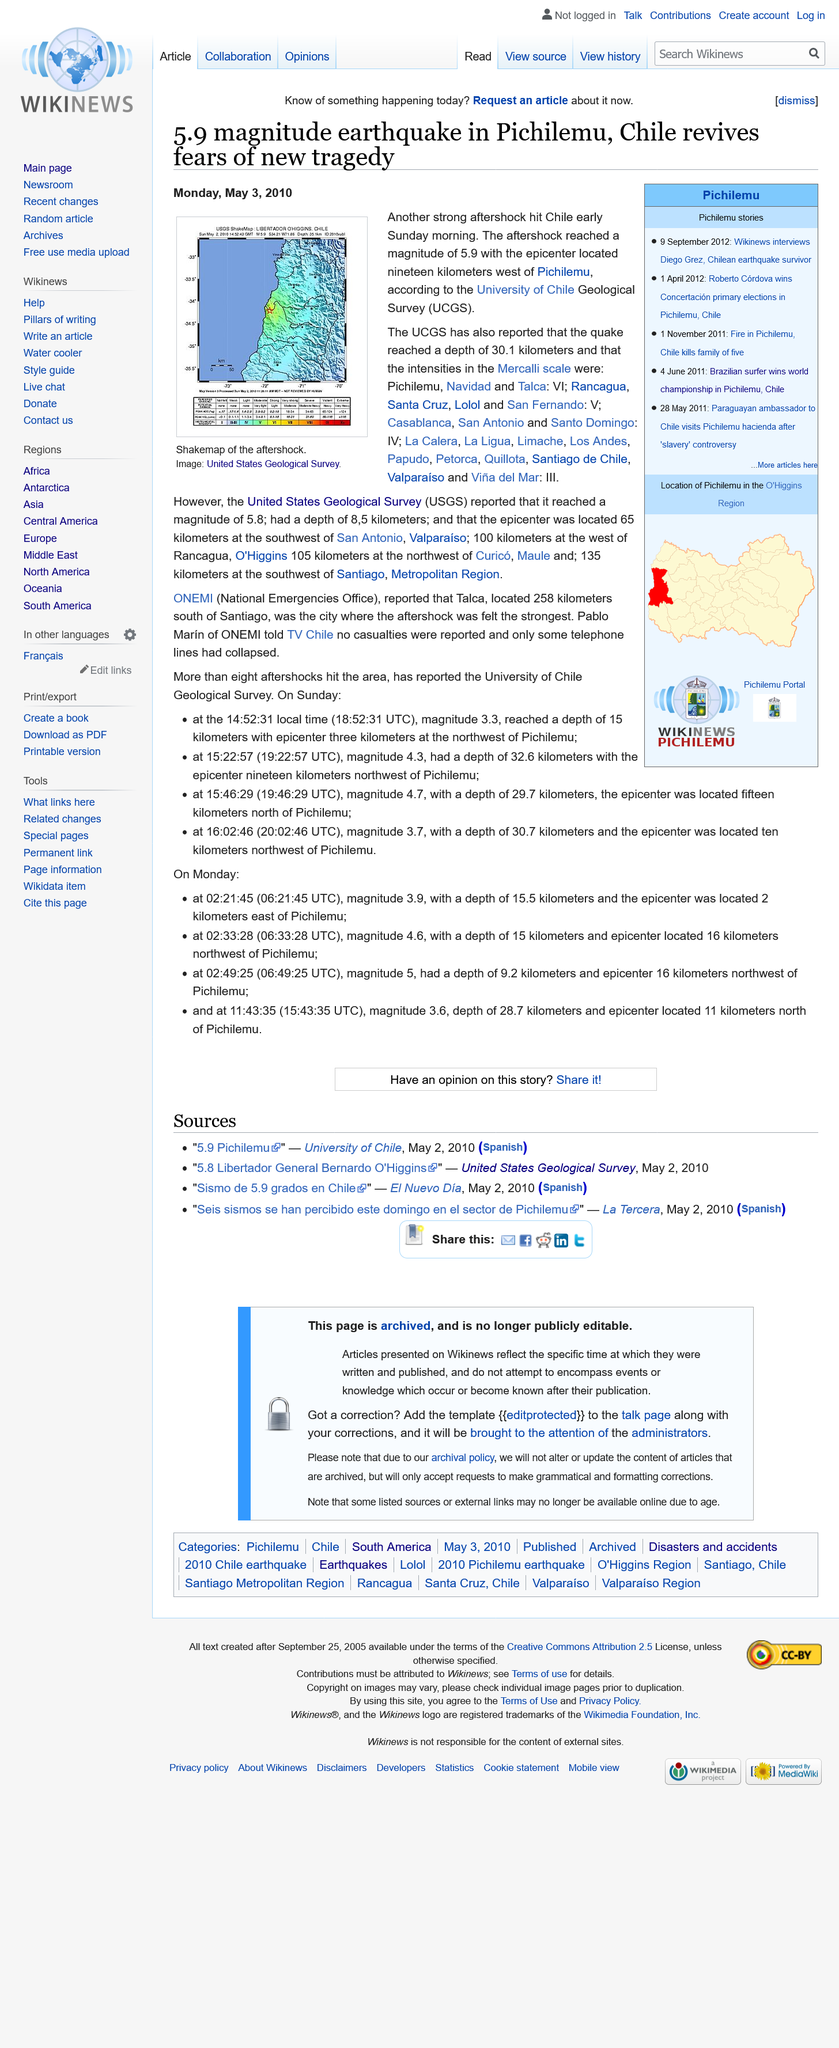Draw attention to some important aspects in this diagram. The depth of the earthquake, as reported by the UCGS, was 30.1 km, while the USGS reported a depth of 8.f km. The University of Chile Geological Survey, commonly abbreviated as UCGS, is a comprehensive survey that provides data and information on geological phenomena and processes within the country of Chile. On Sunday, the earthquake hit Chile, causing destruction and loss of life. 